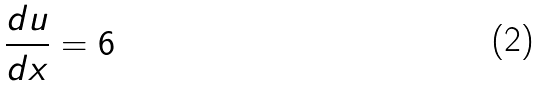<formula> <loc_0><loc_0><loc_500><loc_500>\frac { d u } { d x } = 6</formula> 